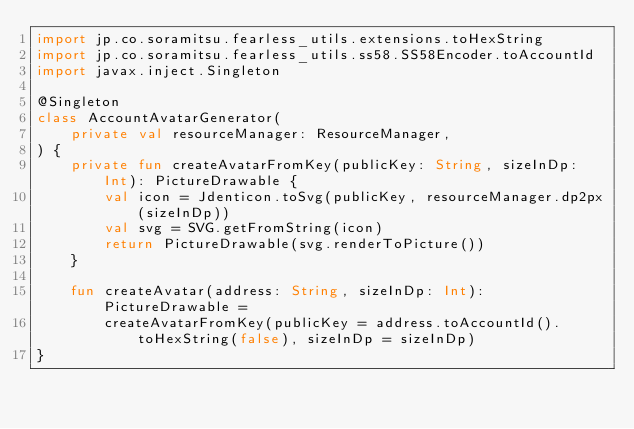Convert code to text. <code><loc_0><loc_0><loc_500><loc_500><_Kotlin_>import jp.co.soramitsu.fearless_utils.extensions.toHexString
import jp.co.soramitsu.fearless_utils.ss58.SS58Encoder.toAccountId
import javax.inject.Singleton

@Singleton
class AccountAvatarGenerator(
    private val resourceManager: ResourceManager,
) {
    private fun createAvatarFromKey(publicKey: String, sizeInDp: Int): PictureDrawable {
        val icon = Jdenticon.toSvg(publicKey, resourceManager.dp2px(sizeInDp))
        val svg = SVG.getFromString(icon)
        return PictureDrawable(svg.renderToPicture())
    }

    fun createAvatar(address: String, sizeInDp: Int): PictureDrawable =
        createAvatarFromKey(publicKey = address.toAccountId().toHexString(false), sizeInDp = sizeInDp)
}
</code> 